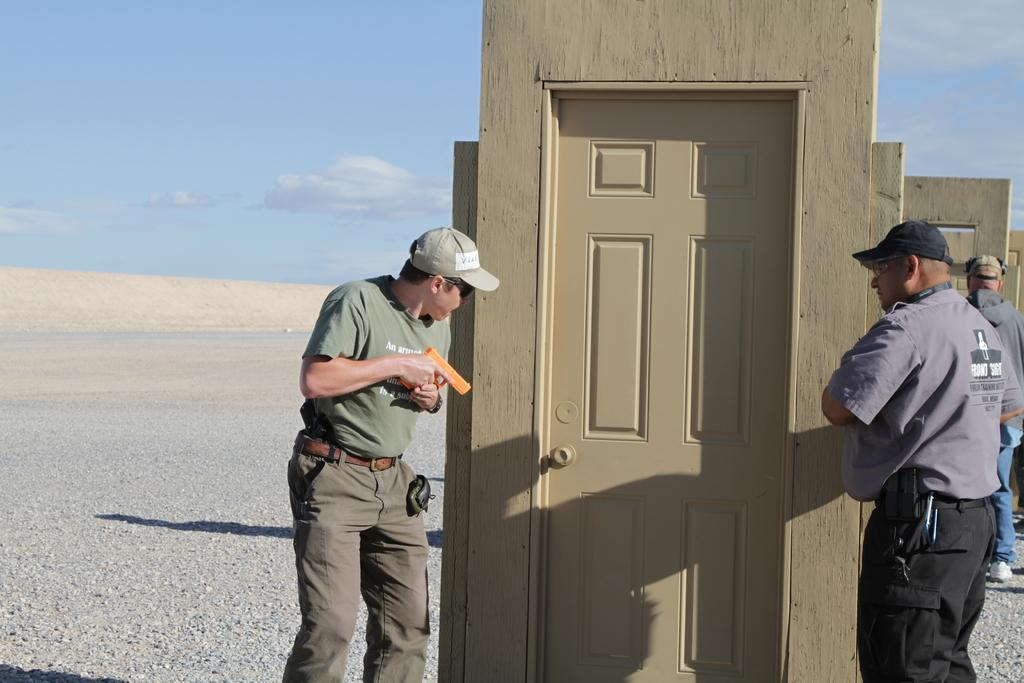How many people are in the image? There are two men in the picture. What are the men doing in the image? The men are on either side of a door. Where is the door located in the image? The door is in the middle of the picture. What can be seen in the background of the image? There are clouds visible in the sky in the background of the image. What type of brain can be seen in the image? There is no brain present in the image. What emotion might the men be feeling as they stand by the door? We cannot determine the emotions of the men from the image alone. 